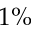<formula> <loc_0><loc_0><loc_500><loc_500>1 \%</formula> 